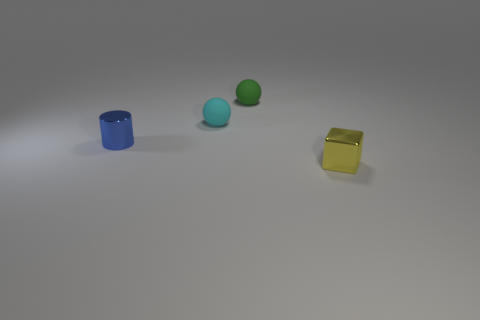What number of rubber spheres are right of the tiny shiny object that is behind the object that is in front of the tiny metallic cylinder?
Offer a terse response. 2. The tiny object that is the same material as the small cylinder is what color?
Your answer should be very brief. Yellow. What number of objects are large purple metal objects or green rubber objects?
Keep it short and to the point. 1. What is the thing in front of the small metallic object behind the small metallic thing on the right side of the tiny blue metallic object made of?
Your response must be concise. Metal. There is a tiny thing on the right side of the small green rubber object; what is it made of?
Your answer should be compact. Metal. Is there a green matte sphere that has the same size as the block?
Give a very brief answer. Yes. What number of purple objects are cubes or shiny things?
Keep it short and to the point. 0. What number of small shiny cylinders have the same color as the shiny block?
Offer a terse response. 0. Are the small blue cylinder and the tiny green ball made of the same material?
Keep it short and to the point. No. What number of small blocks are in front of the metal thing that is to the left of the cyan matte thing?
Offer a very short reply. 1. 